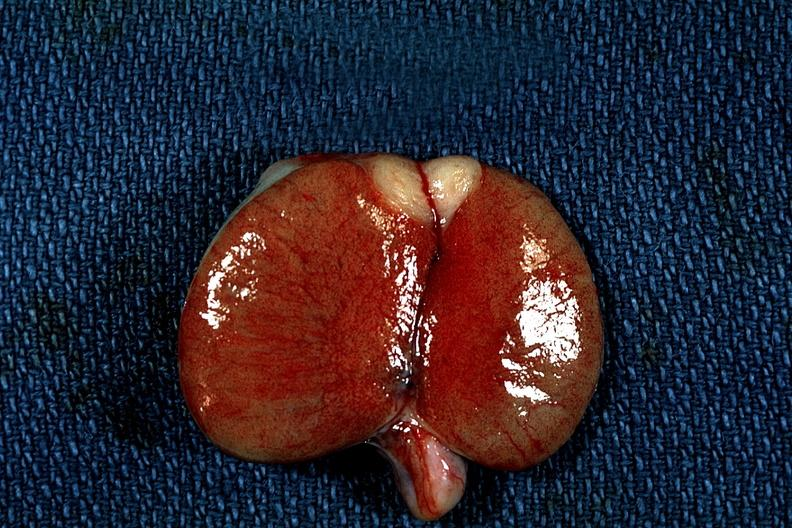s testicle present?
Answer the question using a single word or phrase. No 